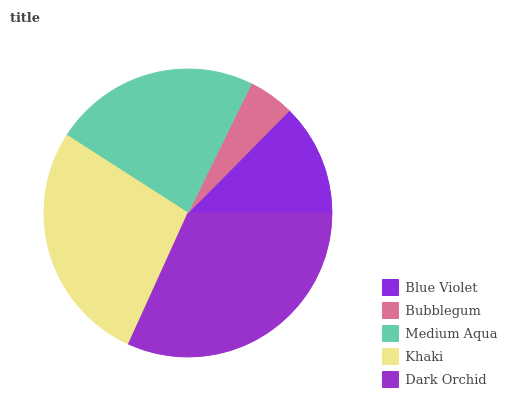Is Bubblegum the minimum?
Answer yes or no. Yes. Is Dark Orchid the maximum?
Answer yes or no. Yes. Is Medium Aqua the minimum?
Answer yes or no. No. Is Medium Aqua the maximum?
Answer yes or no. No. Is Medium Aqua greater than Bubblegum?
Answer yes or no. Yes. Is Bubblegum less than Medium Aqua?
Answer yes or no. Yes. Is Bubblegum greater than Medium Aqua?
Answer yes or no. No. Is Medium Aqua less than Bubblegum?
Answer yes or no. No. Is Medium Aqua the high median?
Answer yes or no. Yes. Is Medium Aqua the low median?
Answer yes or no. Yes. Is Bubblegum the high median?
Answer yes or no. No. Is Blue Violet the low median?
Answer yes or no. No. 